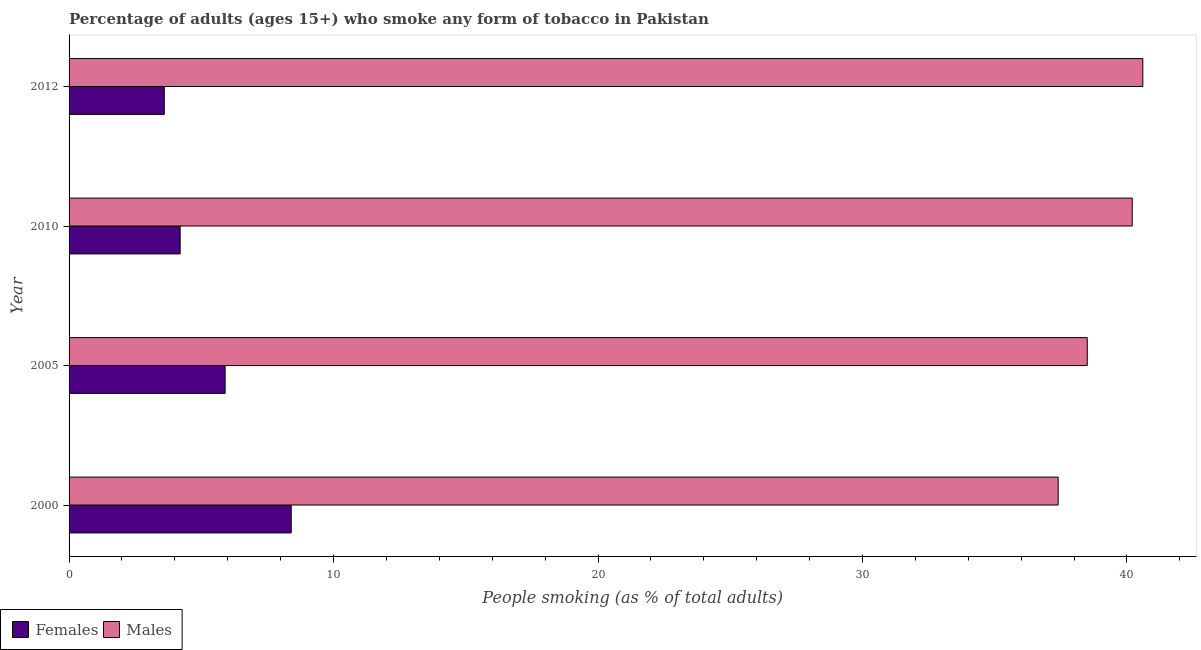How many different coloured bars are there?
Keep it short and to the point. 2. Are the number of bars per tick equal to the number of legend labels?
Offer a terse response. Yes. How many bars are there on the 2nd tick from the top?
Your response must be concise. 2. What is the label of the 1st group of bars from the top?
Give a very brief answer. 2012. What is the percentage of males who smoke in 2012?
Make the answer very short. 40.6. In which year was the percentage of males who smoke maximum?
Offer a terse response. 2012. What is the total percentage of males who smoke in the graph?
Make the answer very short. 156.7. What is the difference between the percentage of males who smoke in 2000 and that in 2005?
Provide a short and direct response. -1.1. What is the difference between the percentage of males who smoke in 2010 and the percentage of females who smoke in 2012?
Offer a very short reply. 36.6. What is the average percentage of males who smoke per year?
Your response must be concise. 39.17. In how many years, is the percentage of females who smoke greater than 4 %?
Give a very brief answer. 3. Is the percentage of females who smoke in 2010 less than that in 2012?
Make the answer very short. No. In how many years, is the percentage of females who smoke greater than the average percentage of females who smoke taken over all years?
Ensure brevity in your answer.  2. Is the sum of the percentage of females who smoke in 2000 and 2005 greater than the maximum percentage of males who smoke across all years?
Give a very brief answer. No. What does the 1st bar from the top in 2010 represents?
Your response must be concise. Males. What does the 1st bar from the bottom in 2000 represents?
Your response must be concise. Females. Are all the bars in the graph horizontal?
Provide a succinct answer. Yes. How many years are there in the graph?
Your answer should be compact. 4. What is the difference between two consecutive major ticks on the X-axis?
Offer a terse response. 10. Are the values on the major ticks of X-axis written in scientific E-notation?
Make the answer very short. No. Does the graph contain any zero values?
Provide a short and direct response. No. Does the graph contain grids?
Your answer should be very brief. No. How many legend labels are there?
Your answer should be compact. 2. How are the legend labels stacked?
Keep it short and to the point. Horizontal. What is the title of the graph?
Make the answer very short. Percentage of adults (ages 15+) who smoke any form of tobacco in Pakistan. What is the label or title of the X-axis?
Offer a terse response. People smoking (as % of total adults). What is the label or title of the Y-axis?
Offer a terse response. Year. What is the People smoking (as % of total adults) of Females in 2000?
Your answer should be very brief. 8.4. What is the People smoking (as % of total adults) in Males in 2000?
Ensure brevity in your answer.  37.4. What is the People smoking (as % of total adults) of Males in 2005?
Keep it short and to the point. 38.5. What is the People smoking (as % of total adults) in Males in 2010?
Your answer should be compact. 40.2. What is the People smoking (as % of total adults) of Females in 2012?
Offer a very short reply. 3.6. What is the People smoking (as % of total adults) in Males in 2012?
Make the answer very short. 40.6. Across all years, what is the maximum People smoking (as % of total adults) in Males?
Keep it short and to the point. 40.6. Across all years, what is the minimum People smoking (as % of total adults) in Males?
Make the answer very short. 37.4. What is the total People smoking (as % of total adults) of Females in the graph?
Your answer should be very brief. 22.1. What is the total People smoking (as % of total adults) in Males in the graph?
Provide a short and direct response. 156.7. What is the difference between the People smoking (as % of total adults) of Females in 2000 and that in 2005?
Make the answer very short. 2.5. What is the difference between the People smoking (as % of total adults) in Females in 2000 and that in 2010?
Keep it short and to the point. 4.2. What is the difference between the People smoking (as % of total adults) of Females in 2005 and that in 2010?
Provide a short and direct response. 1.7. What is the difference between the People smoking (as % of total adults) in Males in 2005 and that in 2010?
Provide a succinct answer. -1.7. What is the difference between the People smoking (as % of total adults) in Females in 2005 and that in 2012?
Keep it short and to the point. 2.3. What is the difference between the People smoking (as % of total adults) of Males in 2005 and that in 2012?
Provide a succinct answer. -2.1. What is the difference between the People smoking (as % of total adults) in Females in 2010 and that in 2012?
Offer a very short reply. 0.6. What is the difference between the People smoking (as % of total adults) in Males in 2010 and that in 2012?
Your answer should be very brief. -0.4. What is the difference between the People smoking (as % of total adults) of Females in 2000 and the People smoking (as % of total adults) of Males in 2005?
Make the answer very short. -30.1. What is the difference between the People smoking (as % of total adults) of Females in 2000 and the People smoking (as % of total adults) of Males in 2010?
Provide a short and direct response. -31.8. What is the difference between the People smoking (as % of total adults) of Females in 2000 and the People smoking (as % of total adults) of Males in 2012?
Make the answer very short. -32.2. What is the difference between the People smoking (as % of total adults) of Females in 2005 and the People smoking (as % of total adults) of Males in 2010?
Your answer should be compact. -34.3. What is the difference between the People smoking (as % of total adults) in Females in 2005 and the People smoking (as % of total adults) in Males in 2012?
Your answer should be compact. -34.7. What is the difference between the People smoking (as % of total adults) of Females in 2010 and the People smoking (as % of total adults) of Males in 2012?
Your answer should be compact. -36.4. What is the average People smoking (as % of total adults) of Females per year?
Give a very brief answer. 5.53. What is the average People smoking (as % of total adults) of Males per year?
Keep it short and to the point. 39.17. In the year 2000, what is the difference between the People smoking (as % of total adults) in Females and People smoking (as % of total adults) in Males?
Your response must be concise. -29. In the year 2005, what is the difference between the People smoking (as % of total adults) in Females and People smoking (as % of total adults) in Males?
Offer a very short reply. -32.6. In the year 2010, what is the difference between the People smoking (as % of total adults) of Females and People smoking (as % of total adults) of Males?
Ensure brevity in your answer.  -36. In the year 2012, what is the difference between the People smoking (as % of total adults) of Females and People smoking (as % of total adults) of Males?
Make the answer very short. -37. What is the ratio of the People smoking (as % of total adults) of Females in 2000 to that in 2005?
Offer a very short reply. 1.42. What is the ratio of the People smoking (as % of total adults) in Males in 2000 to that in 2005?
Your answer should be very brief. 0.97. What is the ratio of the People smoking (as % of total adults) of Males in 2000 to that in 2010?
Provide a succinct answer. 0.93. What is the ratio of the People smoking (as % of total adults) in Females in 2000 to that in 2012?
Your answer should be compact. 2.33. What is the ratio of the People smoking (as % of total adults) in Males in 2000 to that in 2012?
Provide a succinct answer. 0.92. What is the ratio of the People smoking (as % of total adults) in Females in 2005 to that in 2010?
Make the answer very short. 1.4. What is the ratio of the People smoking (as % of total adults) of Males in 2005 to that in 2010?
Provide a succinct answer. 0.96. What is the ratio of the People smoking (as % of total adults) in Females in 2005 to that in 2012?
Your answer should be compact. 1.64. What is the ratio of the People smoking (as % of total adults) of Males in 2005 to that in 2012?
Provide a succinct answer. 0.95. What is the ratio of the People smoking (as % of total adults) in Males in 2010 to that in 2012?
Your answer should be compact. 0.99. What is the difference between the highest and the lowest People smoking (as % of total adults) in Females?
Your answer should be very brief. 4.8. What is the difference between the highest and the lowest People smoking (as % of total adults) in Males?
Make the answer very short. 3.2. 